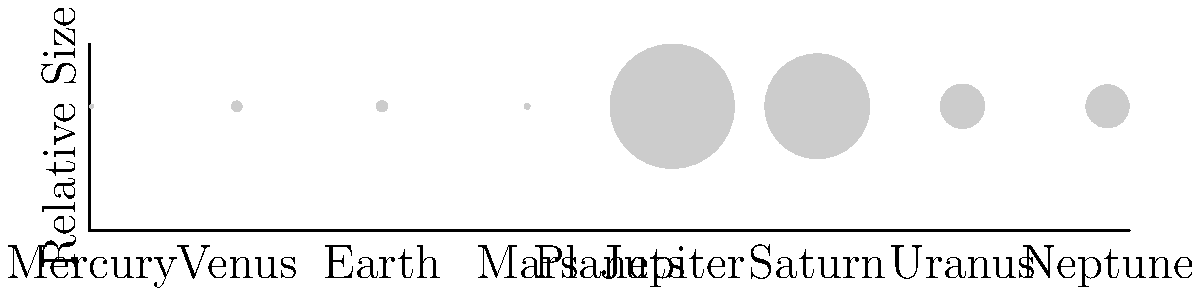As a retired physician who has spent years observing and analyzing details, consider the relative sizes of planets in our solar system. Which planet stands out as significantly larger than the others, and how does its size compare to Earth's? Let's analyze this step-by-step:

1. Observe the graphic, which shows the relative sizes of the eight planets in our solar system.

2. Notice that one planet is significantly larger than all the others. This is Jupiter.

3. To compare Jupiter's size to Earth's, we need to estimate their relative diameters from the graphic.

4. Earth's diameter is approximately 12,756 km.

5. Jupiter's diameter is about 142,984 km.

6. To calculate how many times larger Jupiter is than Earth:
   $$ \frac{\text{Jupiter's diameter}}{\text{Earth's diameter}} = \frac{142,984}{12,756} \approx 11.21 $$

7. This means Jupiter is about 11 times larger in diameter than Earth.

8. Remember that this is just the diameter. In terms of volume, the difference would be even more significant, as volume scales with the cube of the diameter.
Answer: Jupiter; approximately 11 times larger in diameter than Earth 